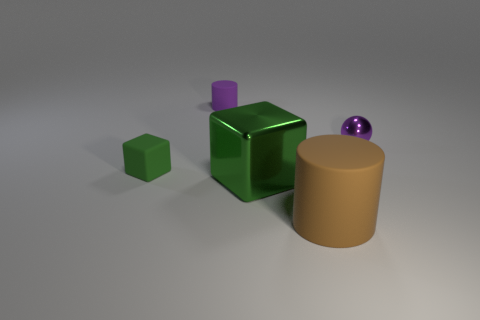What is the shape of the small green thing?
Offer a very short reply. Cube. What number of other things are made of the same material as the tiny sphere?
Offer a very short reply. 1. There is a shiny object that is the same shape as the tiny green rubber thing; what is its size?
Provide a short and direct response. Large. The tiny green block on the left side of the matte object behind the green block that is left of the big green cube is made of what material?
Offer a terse response. Rubber. Is there a purple rubber thing?
Your answer should be compact. Yes. Is the color of the tiny shiny thing the same as the rubber cylinder that is behind the tiny ball?
Ensure brevity in your answer.  Yes. The small matte cylinder is what color?
Make the answer very short. Purple. Is there anything else that is the same shape as the big brown object?
Give a very brief answer. Yes. There is another thing that is the same shape as the large green shiny object; what color is it?
Your answer should be very brief. Green. Does the brown matte thing have the same shape as the tiny green rubber thing?
Offer a terse response. No. 